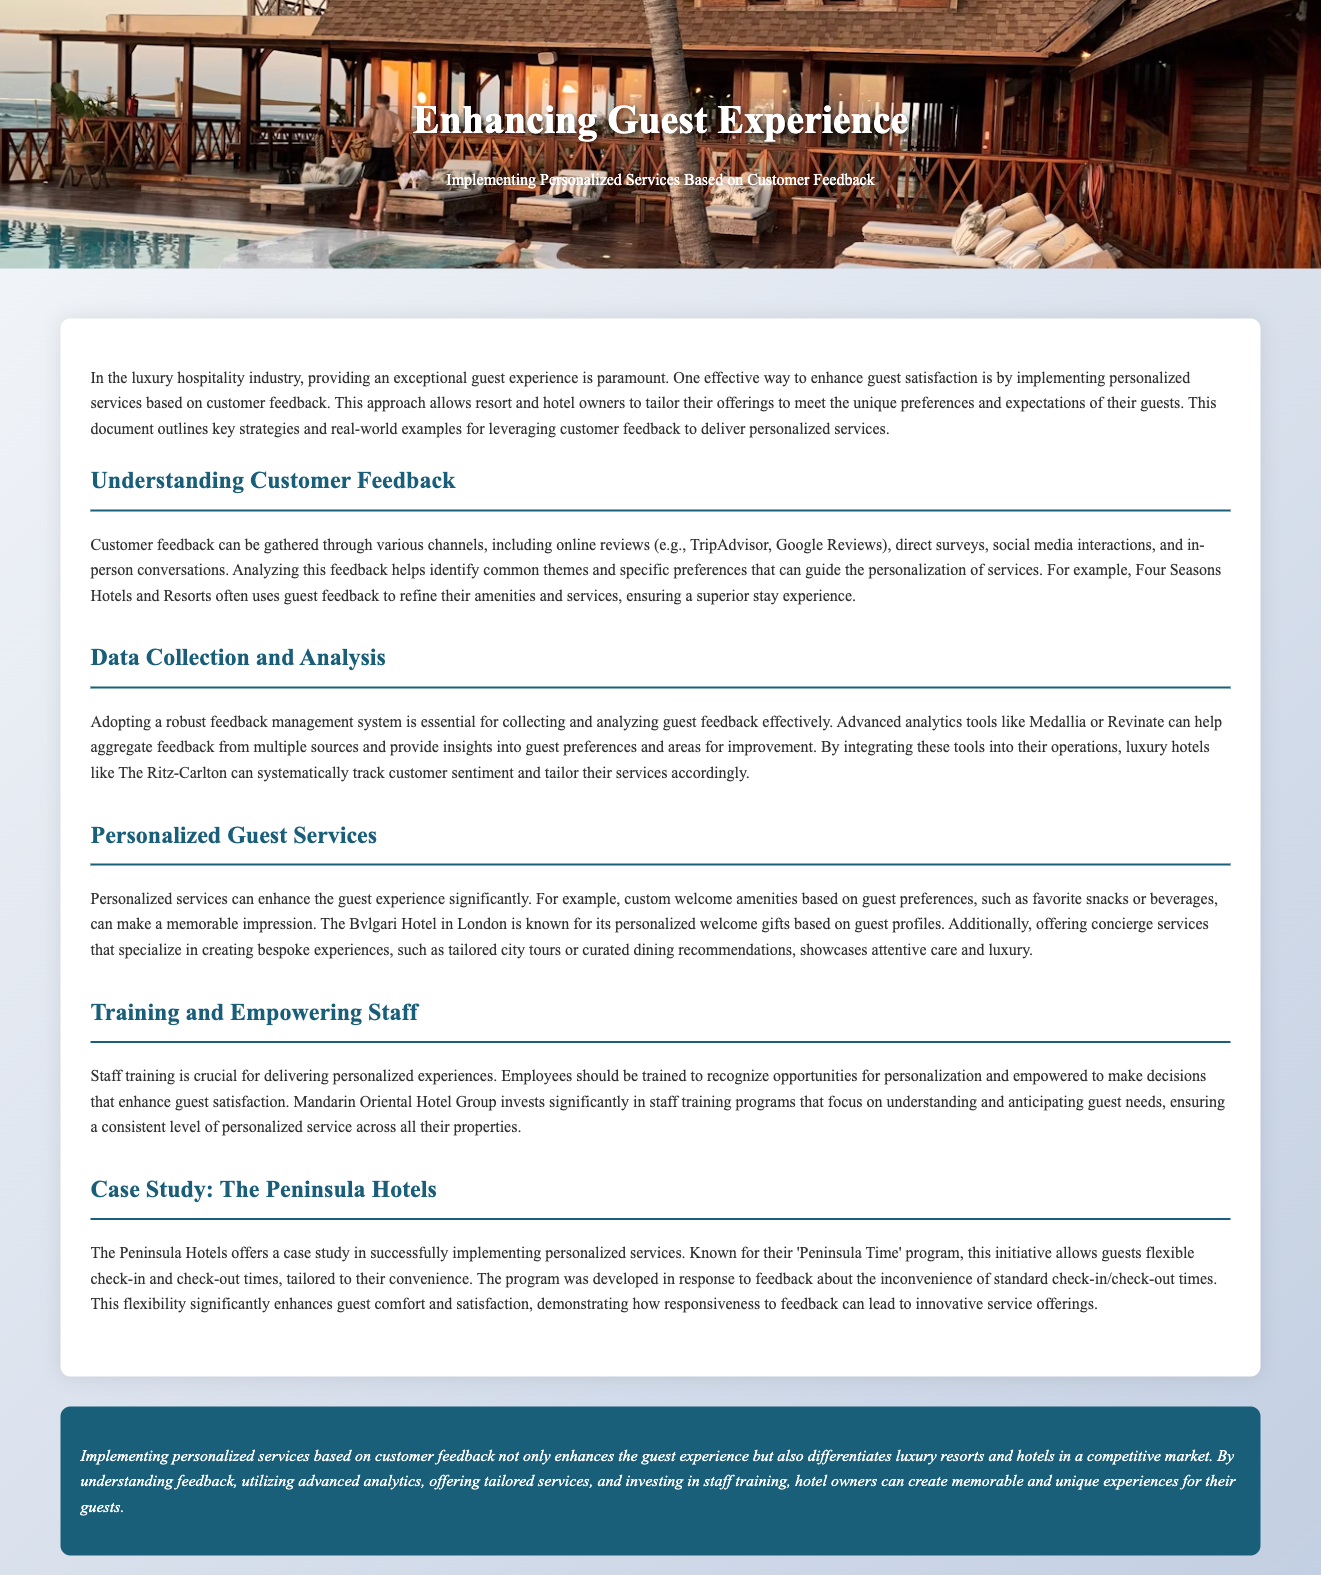What is the title of the document? The title is provided in the document, encapsulating the main theme of the homework.
Answer: Enhancing Guest Experience What is the primary focus of the document? The document details strategies for improving guest satisfaction in luxury hospitality through personalized services.
Answer: Personalized Services Which hotel is known for its 'Peninsula Time' program? The document provides a case study on a specific hotel known for this initiative.
Answer: The Peninsula Hotels What feedback collection methods are mentioned? The document lists several channels through which guest feedback can be gathered and analyzed for enhancing services.
Answer: Online reviews, direct surveys, social media, in-person conversations What brand emphasizes training staff in understanding guest needs? The document highlights a specific luxury hotel group that invests in training programs for staff empowerment.
Answer: Mandarin Oriental Hotel Group How does the Bvlgari Hotel in London personalize guest experiences? The document includes specific examples of how this hotel tailors its approach based on guest preferences.
Answer: Personalized welcome gifts What technology is suggested for gathering and analyzing guest feedback? The document mentions advanced analytics tools that can help luxury hotels improve their services.
Answer: Medallia or Revinate What is one benefit of implementing personalized services? The document outlines a key advantage of tailoring services to the individual needs of guests.
Answer: Enhances guest experience Which aspect is crucial for delivering personalized experiences according to the document? The document identifies an important component necessary for the successful implementation of personalized guest services.
Answer: Staff training 